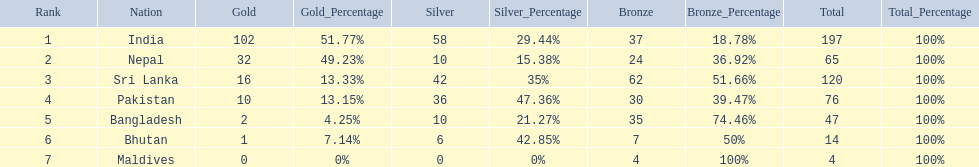What nations took part in 1999 south asian games? India, Nepal, Sri Lanka, Pakistan, Bangladesh, Bhutan, Maldives. Of those who earned gold medals? India, Nepal, Sri Lanka, Pakistan, Bangladesh, Bhutan. Which nation didn't earn any gold medals? Maldives. 